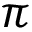Convert formula to latex. <formula><loc_0><loc_0><loc_500><loc_500>\pi</formula> 